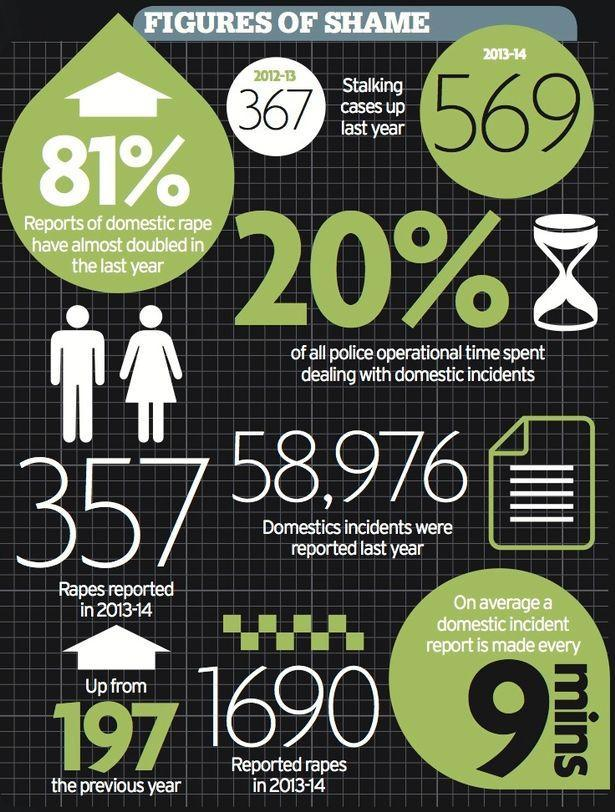How many domestic incident report is made every 1.5 hours
Answer the question with a short phrase. 10 how much has the % of domestic rape increased from last year 81% What has been the increase in the reported rape cases from 2012-13 197 How much has the stalking cases increased in 2013-14 from 2012-13 202 What % of police operational time is spent on activities other than domestic incidents 80 